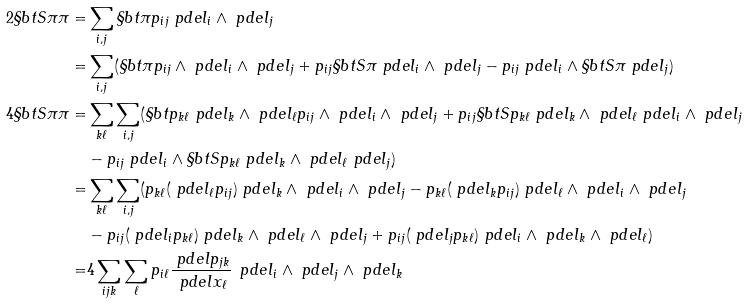<formula> <loc_0><loc_0><loc_500><loc_500>2 \S b t S { \pi } { \pi } = & \sum _ { i , j } \S b t { \pi } { p _ { i j } \ p d e l _ { i } \wedge \ p d e l _ { j } } \\ = & \sum _ { i , j } ( \S b t { \pi } { p _ { i j } } \wedge \ p d e l _ { i } \wedge \ p d e l _ { j } + p _ { i j } \S b t S { \pi } { \ p d e l _ { i } } \wedge \ p d e l _ { j } - p _ { i j } \ p d e l _ { i } \wedge \S b t S { \pi } { \ p d e l _ { j } } ) \\ 4 \S b t S { \pi } { \pi } = & \sum _ { k \ell } \sum _ { i , j } ( \S b t { p _ { k \ell } \ p d e l _ { k } \wedge \ p d e l _ { \ell } } { p _ { i j } } \wedge \ p d e l _ { i } \wedge \ p d e l _ { j } + p _ { i j } \S b t S { p _ { k \ell } \ p d e l _ { k } \wedge \ p d e l _ { \ell } } { \ p d e l _ { i } } \wedge \ p d e l _ { j } \\ & - p _ { i j } \ p d e l _ { i } \wedge \S b t S { p _ { k \ell } \ p d e l _ { k } \wedge \ p d e l _ { \ell } } { \ p d e l _ { j } } ) \\ = & \sum _ { k \ell } \sum _ { i , j } ( p _ { k \ell } ( \ p d e l _ { \ell } p _ { i j } ) \ p d e l _ { k } \wedge \ p d e l _ { i } \wedge \ p d e l _ { j } - p _ { k \ell } ( \ p d e l _ { k } p _ { i j } ) \ p d e l _ { \ell } \wedge \ p d e l _ { i } \wedge \ p d e l _ { j } \\ & - p _ { i j } ( \ p d e l _ { i } p _ { k \ell } ) \ p d e l _ { k } \wedge \ p d e l _ { \ell } \wedge \ p d e l _ { j } + p _ { i j } ( \ p d e l _ { j } p _ { k \ell } ) \ p d e l _ { i } \wedge \ p d e l _ { k } \wedge \ p d e l _ { \ell } ) \\ = & 4 \sum _ { i j k } \sum _ { \ell } p _ { i \ell } \frac { \ p d e l p _ { j k } } { \ p d e l x _ { \ell } } \, \ p d e l _ { i } \wedge \ p d e l _ { j } \wedge \ p d e l _ { k }</formula> 